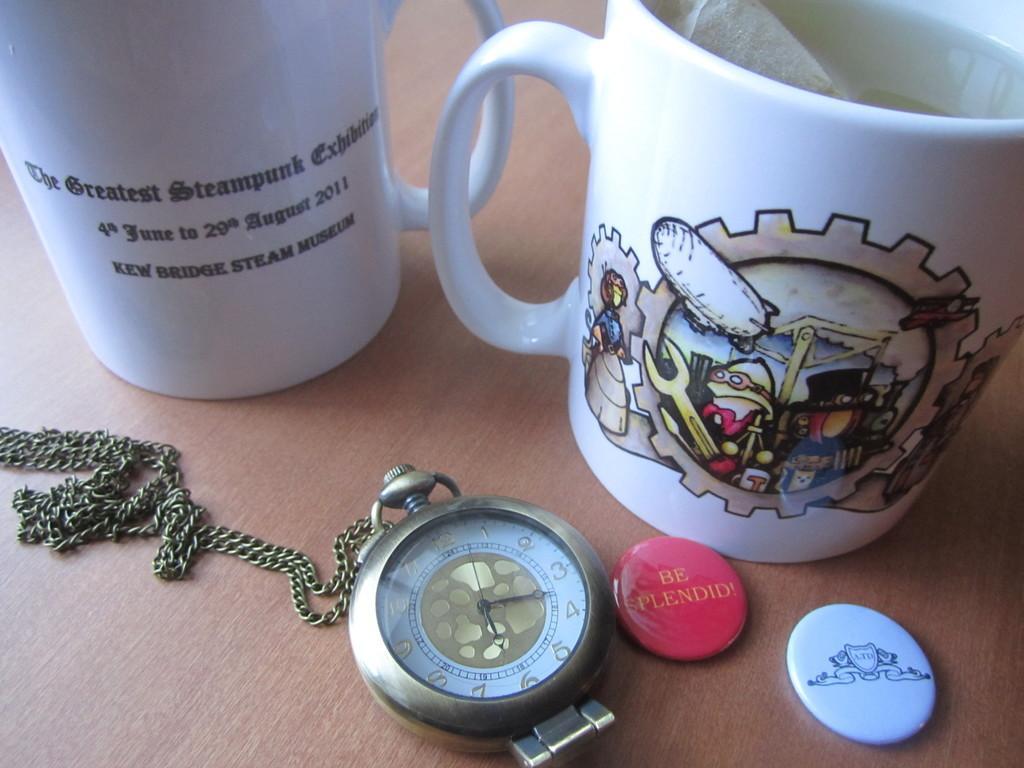Can you describe this image briefly? In this image we can see chain to the pocket clock, badges which are in red and white color and two cups on one we can see some text and an image on it which are kept on the wooden surface. 